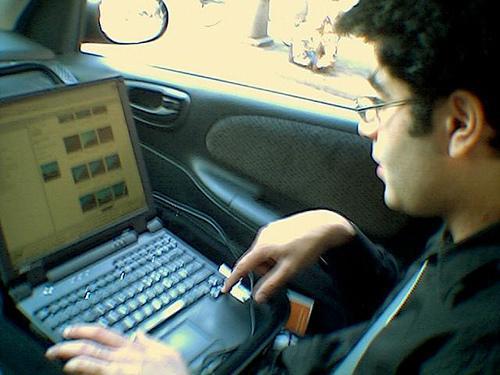How many people are there?
Give a very brief answer. 1. 